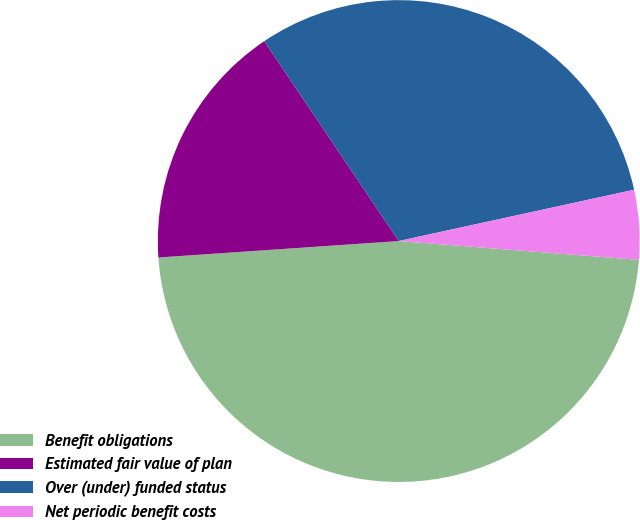Convert chart to OTSL. <chart><loc_0><loc_0><loc_500><loc_500><pie_chart><fcel>Benefit obligations<fcel>Estimated fair value of plan<fcel>Over (under) funded status<fcel>Net periodic benefit costs<nl><fcel>47.67%<fcel>16.66%<fcel>31.01%<fcel>4.66%<nl></chart> 